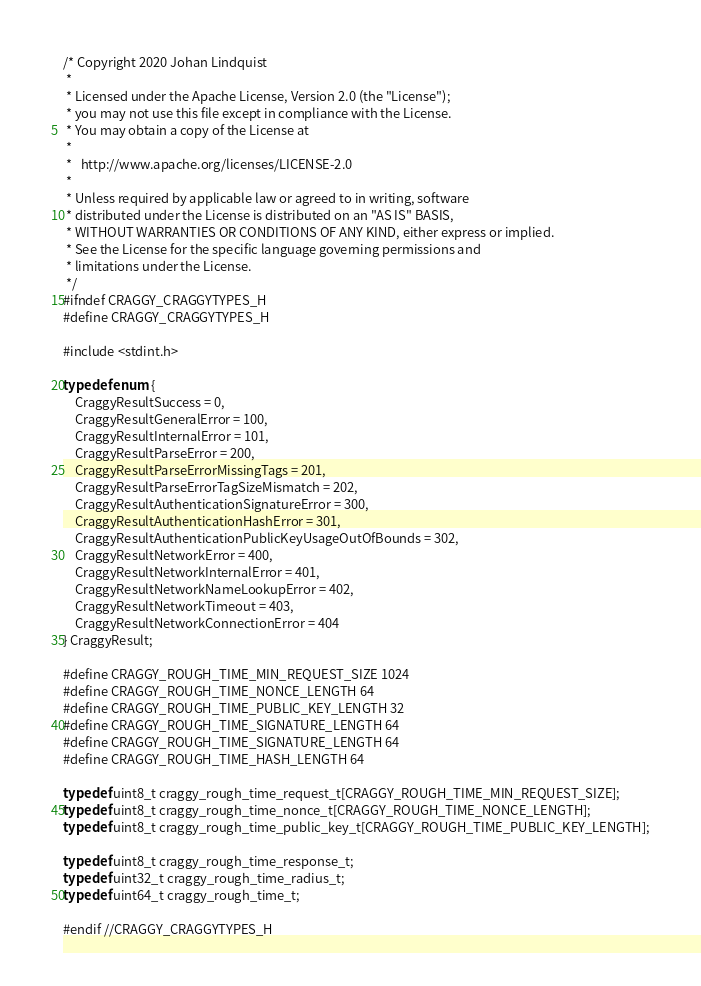<code> <loc_0><loc_0><loc_500><loc_500><_C_>/* Copyright 2020 Johan Lindquist
 *
 * Licensed under the Apache License, Version 2.0 (the "License");
 * you may not use this file except in compliance with the License.
 * You may obtain a copy of the License at
 *
 *   http://www.apache.org/licenses/LICENSE-2.0
 *
 * Unless required by applicable law or agreed to in writing, software
 * distributed under the License is distributed on an "AS IS" BASIS,
 * WITHOUT WARRANTIES OR CONDITIONS OF ANY KIND, either express or implied.
 * See the License for the specific language governing permissions and
 * limitations under the License.
 */
#ifndef CRAGGY_CRAGGYTYPES_H
#define CRAGGY_CRAGGYTYPES_H

#include <stdint.h>

typedef enum {
    CraggyResultSuccess = 0,
    CraggyResultGeneralError = 100,
    CraggyResultInternalError = 101,
    CraggyResultParseError = 200,
    CraggyResultParseErrorMissingTags = 201,
    CraggyResultParseErrorTagSizeMismatch = 202,
    CraggyResultAuthenticationSignatureError = 300,
    CraggyResultAuthenticationHashError = 301,
    CraggyResultAuthenticationPublicKeyUsageOutOfBounds = 302,
    CraggyResultNetworkError = 400,
    CraggyResultNetworkInternalError = 401,
    CraggyResultNetworkNameLookupError = 402,
    CraggyResultNetworkTimeout = 403,
    CraggyResultNetworkConnectionError = 404
} CraggyResult;

#define CRAGGY_ROUGH_TIME_MIN_REQUEST_SIZE 1024
#define CRAGGY_ROUGH_TIME_NONCE_LENGTH 64
#define CRAGGY_ROUGH_TIME_PUBLIC_KEY_LENGTH 32
#define CRAGGY_ROUGH_TIME_SIGNATURE_LENGTH 64
#define CRAGGY_ROUGH_TIME_SIGNATURE_LENGTH 64
#define CRAGGY_ROUGH_TIME_HASH_LENGTH 64

typedef uint8_t craggy_rough_time_request_t[CRAGGY_ROUGH_TIME_MIN_REQUEST_SIZE];
typedef uint8_t craggy_rough_time_nonce_t[CRAGGY_ROUGH_TIME_NONCE_LENGTH];
typedef uint8_t craggy_rough_time_public_key_t[CRAGGY_ROUGH_TIME_PUBLIC_KEY_LENGTH];

typedef uint8_t craggy_rough_time_response_t;
typedef uint32_t craggy_rough_time_radius_t;
typedef uint64_t craggy_rough_time_t;

#endif //CRAGGY_CRAGGYTYPES_H
</code> 